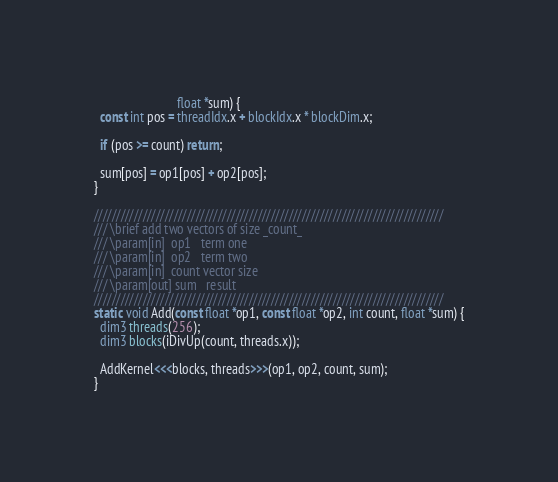Convert code to text. <code><loc_0><loc_0><loc_500><loc_500><_Cuda_>                          float *sum) {
  const int pos = threadIdx.x + blockIdx.x * blockDim.x;

  if (pos >= count) return;

  sum[pos] = op1[pos] + op2[pos];
}

///////////////////////////////////////////////////////////////////////////////
/// \brief add two vectors of size _count_
/// \param[in]  op1   term one
/// \param[in]  op2   term two
/// \param[in]  count vector size
/// \param[out] sum   result
///////////////////////////////////////////////////////////////////////////////
static void Add(const float *op1, const float *op2, int count, float *sum) {
  dim3 threads(256);
  dim3 blocks(iDivUp(count, threads.x));

  AddKernel<<<blocks, threads>>>(op1, op2, count, sum);
}
</code> 